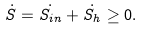<formula> <loc_0><loc_0><loc_500><loc_500>\dot { S } = \dot { S _ { i n } } + \dot { S _ { h } } \geq 0 .</formula> 